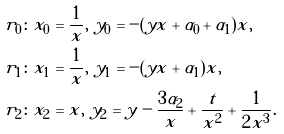<formula> <loc_0><loc_0><loc_500><loc_500>r _ { 0 } & \colon x _ { 0 } = \frac { 1 } { x } , \ y _ { 0 } = - ( y x + \alpha _ { 0 } + \alpha _ { 1 } ) x , \\ r _ { 1 } & \colon x _ { 1 } = \frac { 1 } { x } , \ y _ { 1 } = - ( y x + \alpha _ { 1 } ) x , \\ r _ { 2 } & \colon x _ { 2 } = x , \ y _ { 2 } = y - \frac { 3 \alpha _ { 2 } } { x } + \frac { t } { x ^ { 2 } } + \frac { 1 } { 2 x ^ { 3 } } .</formula> 